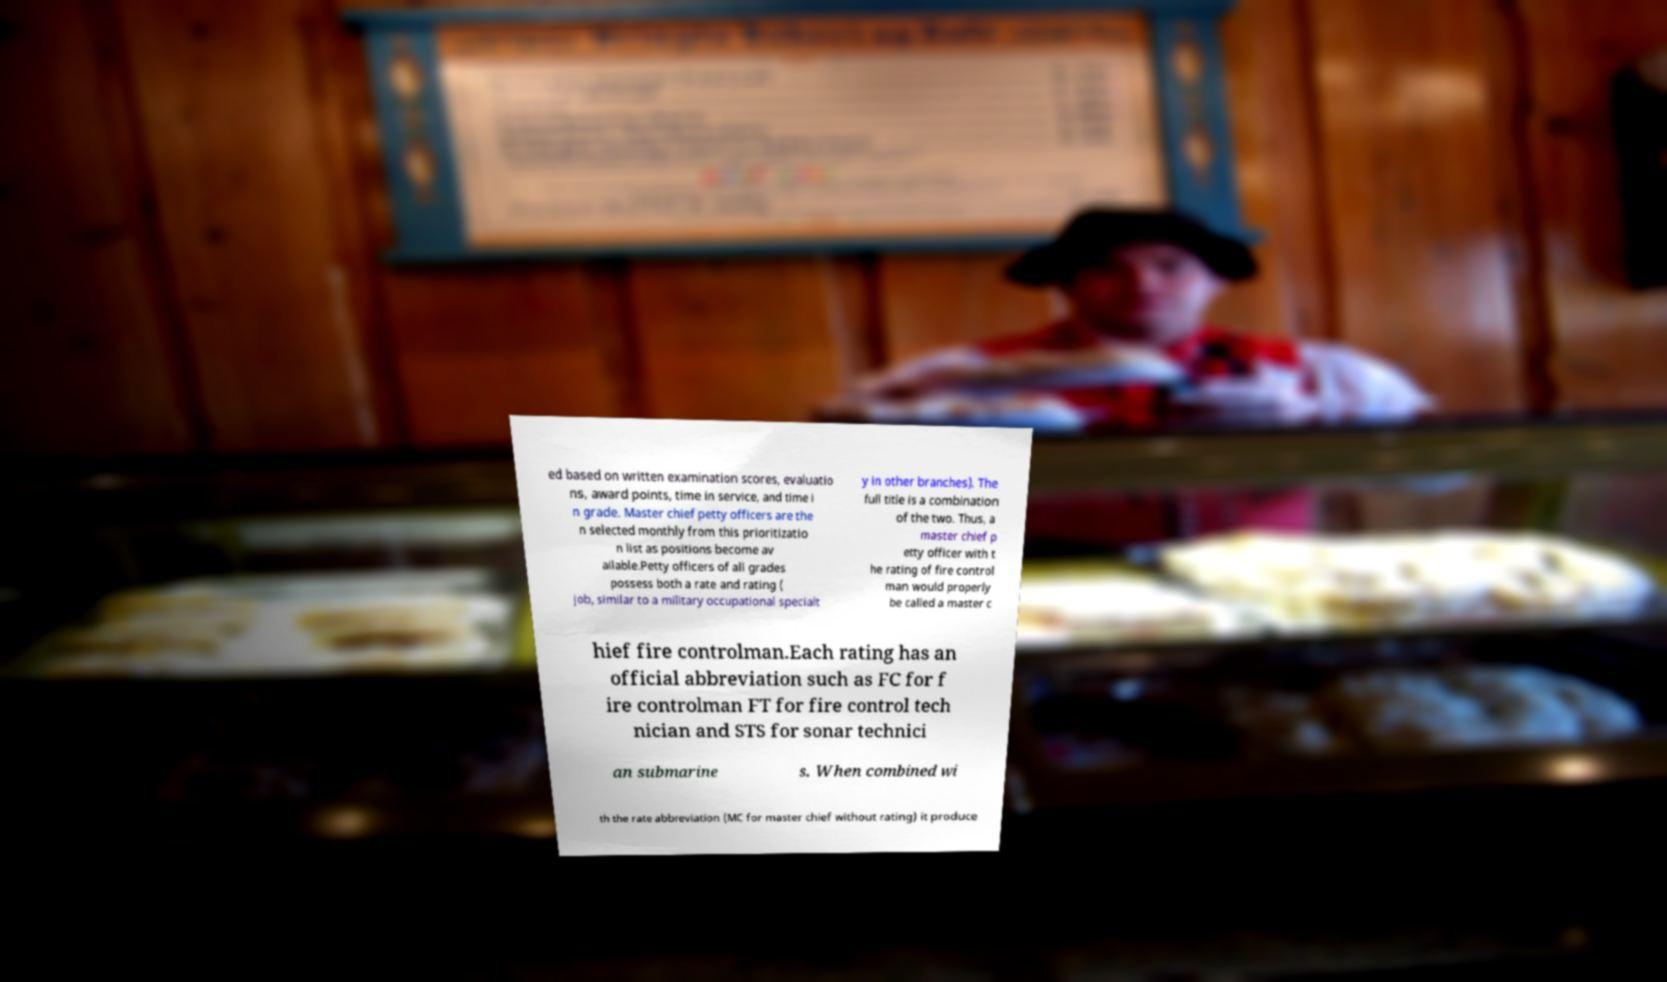Could you assist in decoding the text presented in this image and type it out clearly? ed based on written examination scores, evaluatio ns, award points, time in service, and time i n grade. Master chief petty officers are the n selected monthly from this prioritizatio n list as positions become av ailable.Petty officers of all grades possess both a rate and rating ( job, similar to a military occupational specialt y in other branches). The full title is a combination of the two. Thus, a master chief p etty officer with t he rating of fire control man would properly be called a master c hief fire controlman.Each rating has an official abbreviation such as FC for f ire controlman FT for fire control tech nician and STS for sonar technici an submarine s. When combined wi th the rate abbreviation (MC for master chief without rating) it produce 